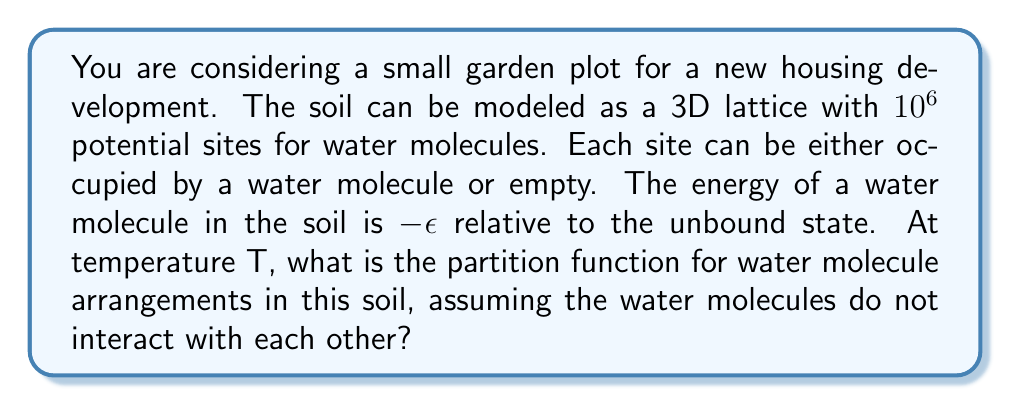Show me your answer to this math problem. To solve this problem, we'll follow these steps:

1) In statistical mechanics, the partition function Z for a system with discrete energy levels is given by:

   $$Z = \sum_i g_i e^{-\beta E_i}$$

   where $g_i$ is the degeneracy of energy level $E_i$, and $\beta = \frac{1}{k_B T}$.

2) In our case, each site has two possible states:
   - Occupied: $E = -\epsilon$
   - Empty: $E = 0$

3) For each site, we can write a partition function:

   $$z = e^{\beta\epsilon} + 1$$

4) Since there are $10^6$ independent sites, and the water molecules don't interact, we can use the multiplication rule. The total partition function is:

   $$Z = z^{10^6} = (e^{\beta\epsilon} + 1)^{10^6}$$

5) This can be rewritten as:

   $$Z = \exp(10^6 \ln(e^{\beta\epsilon} + 1))$$

This is the partition function for water molecule arrangements in the soil.
Answer: $Z = \exp(10^6 \ln(e^{\beta\epsilon} + 1))$ 